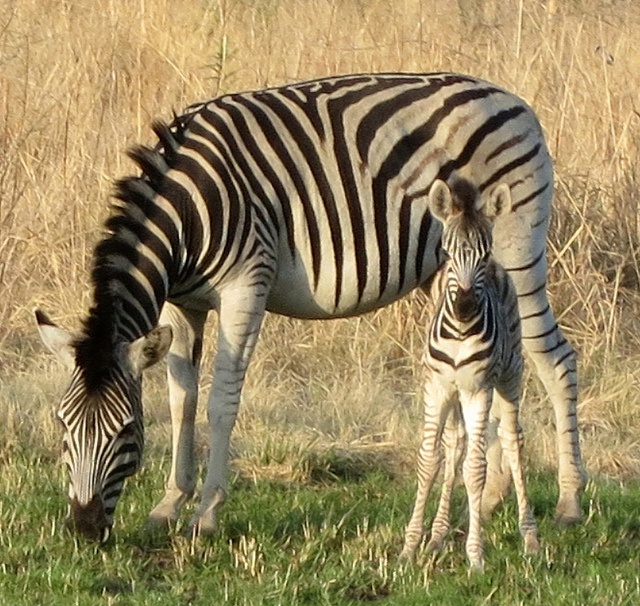Describe the objects in this image and their specific colors. I can see zebra in tan, black, and gray tones and zebra in tan, beige, and gray tones in this image. 